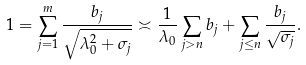<formula> <loc_0><loc_0><loc_500><loc_500>1 = \sum _ { j = 1 } ^ { m } \frac { b _ { j } } { \sqrt { \lambda _ { 0 } ^ { 2 } + \sigma _ { j } } } \asymp \frac { 1 } { \lambda _ { 0 } } \sum _ { j > n } b _ { j } + \sum _ { j \leq n } \frac { b _ { j } } { \sqrt { \sigma _ { j } } } .</formula> 